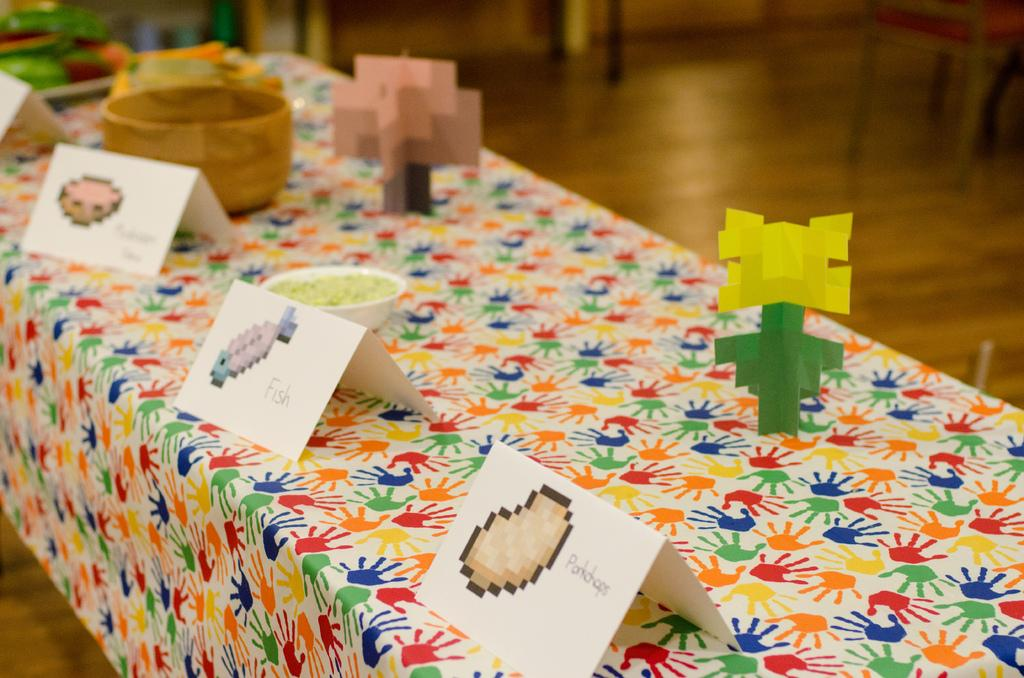What is depicted on the cards in the image? There are pictures on cards in the image. What is in the bowl that is visible in the image? There is an item in a bowl in the image. What type of paper is present in the image? There are design papers in the image. What is the primary location of the objects in the image? There are objects on a table in the image. What can be seen in the background of the image? There are chairs on the floor and other objects visible in the background of the image. Can you see a lake in the background of the image? There is no lake visible in the background of the image. Is there a cannon present on the table in the image? There is no cannon present in the image. 